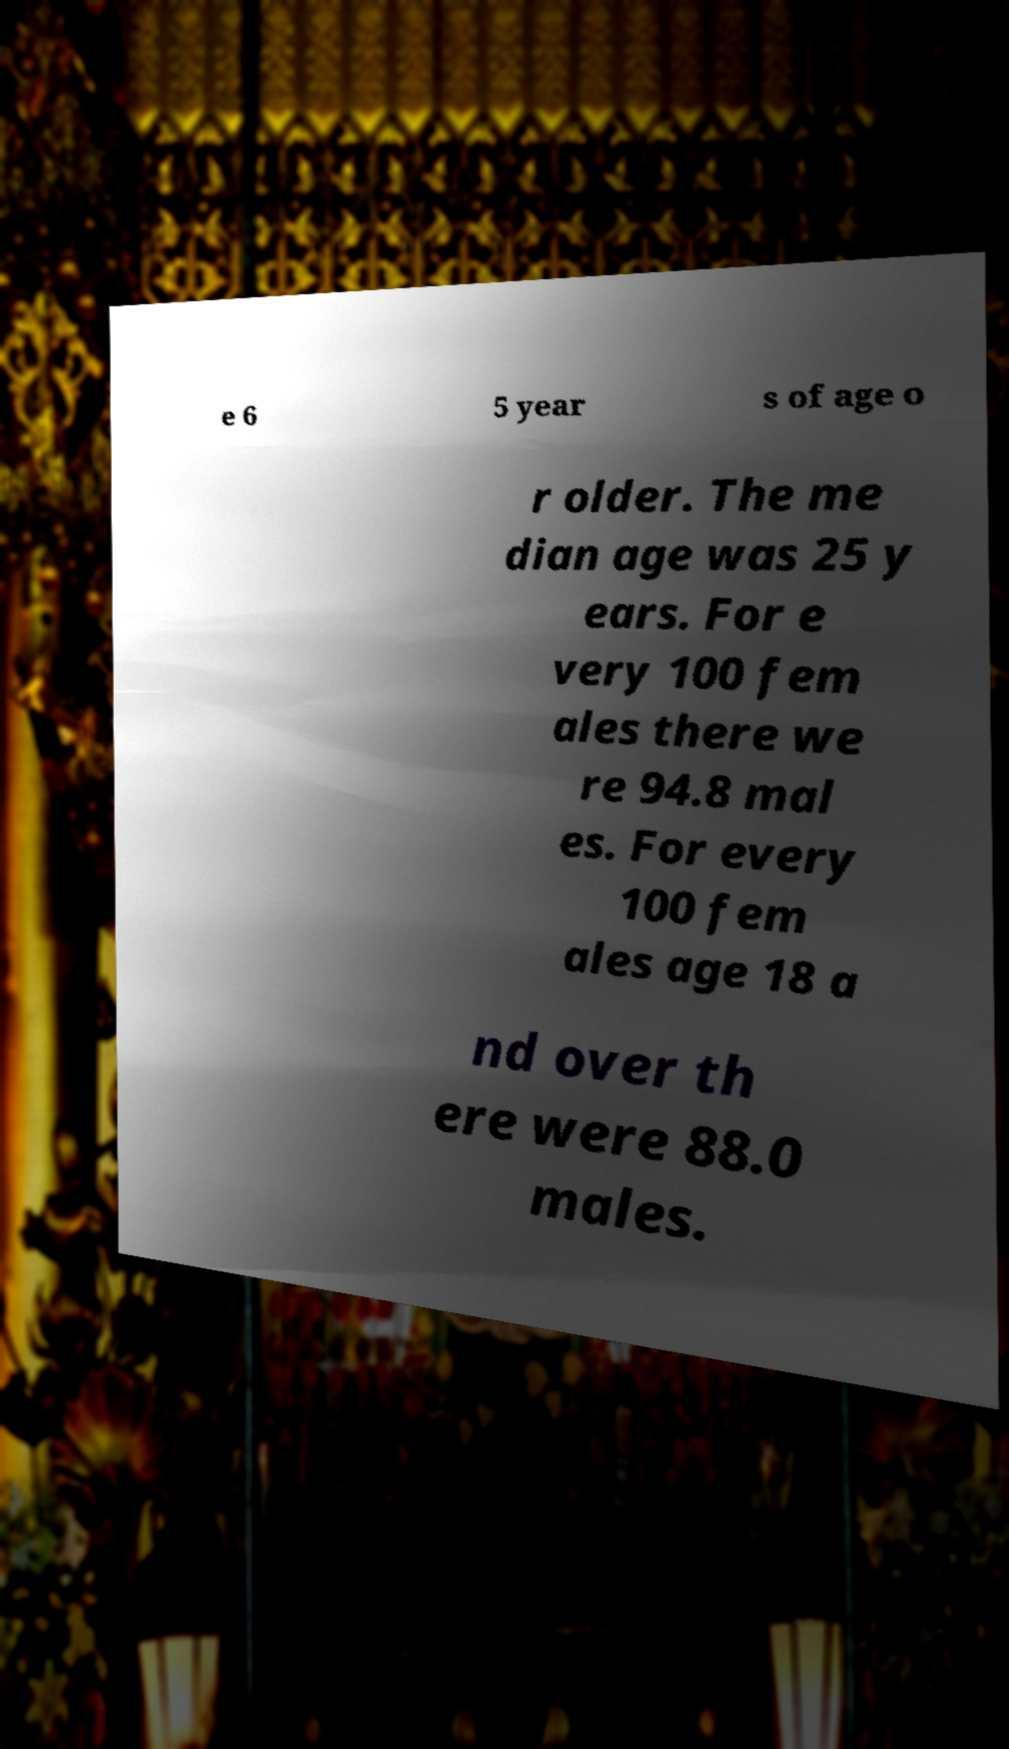Could you assist in decoding the text presented in this image and type it out clearly? e 6 5 year s of age o r older. The me dian age was 25 y ears. For e very 100 fem ales there we re 94.8 mal es. For every 100 fem ales age 18 a nd over th ere were 88.0 males. 